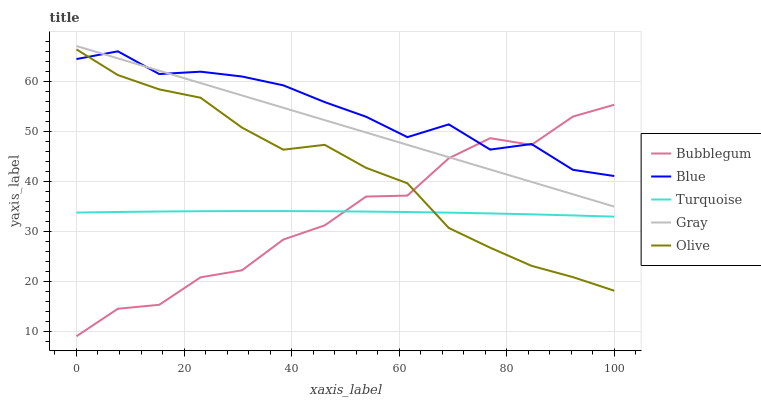Does Bubblegum have the minimum area under the curve?
Answer yes or no. Yes. Does Blue have the maximum area under the curve?
Answer yes or no. Yes. Does Gray have the minimum area under the curve?
Answer yes or no. No. Does Gray have the maximum area under the curve?
Answer yes or no. No. Is Gray the smoothest?
Answer yes or no. Yes. Is Bubblegum the roughest?
Answer yes or no. Yes. Is Turquoise the smoothest?
Answer yes or no. No. Is Turquoise the roughest?
Answer yes or no. No. Does Bubblegum have the lowest value?
Answer yes or no. Yes. Does Gray have the lowest value?
Answer yes or no. No. Does Gray have the highest value?
Answer yes or no. Yes. Does Turquoise have the highest value?
Answer yes or no. No. Is Olive less than Gray?
Answer yes or no. Yes. Is Blue greater than Turquoise?
Answer yes or no. Yes. Does Gray intersect Bubblegum?
Answer yes or no. Yes. Is Gray less than Bubblegum?
Answer yes or no. No. Is Gray greater than Bubblegum?
Answer yes or no. No. Does Olive intersect Gray?
Answer yes or no. No. 